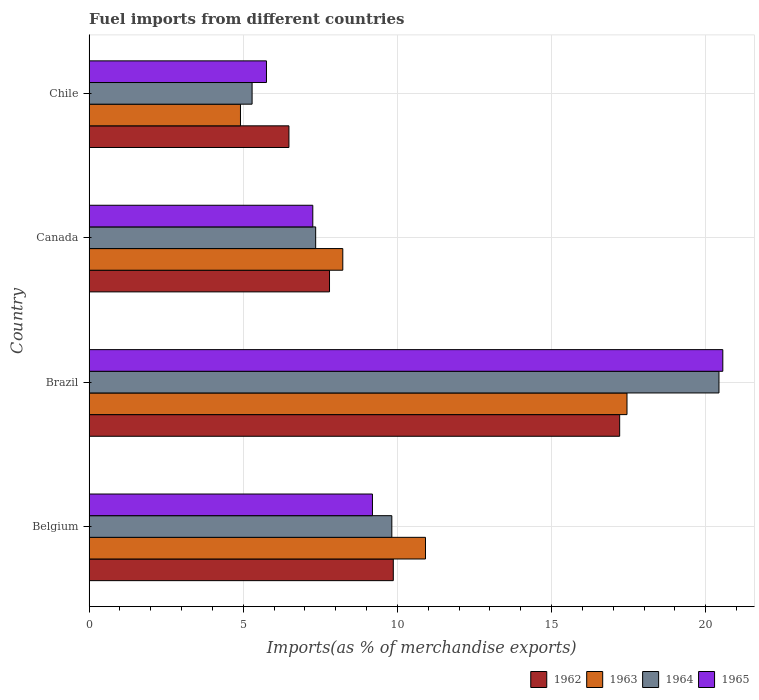How many different coloured bars are there?
Ensure brevity in your answer.  4. How many groups of bars are there?
Offer a terse response. 4. Are the number of bars per tick equal to the number of legend labels?
Ensure brevity in your answer.  Yes. Are the number of bars on each tick of the Y-axis equal?
Make the answer very short. Yes. What is the percentage of imports to different countries in 1964 in Canada?
Your answer should be compact. 7.35. Across all countries, what is the maximum percentage of imports to different countries in 1964?
Your answer should be compact. 20.43. Across all countries, what is the minimum percentage of imports to different countries in 1962?
Offer a terse response. 6.48. In which country was the percentage of imports to different countries in 1963 minimum?
Your answer should be very brief. Chile. What is the total percentage of imports to different countries in 1964 in the graph?
Provide a succinct answer. 42.88. What is the difference between the percentage of imports to different countries in 1964 in Brazil and that in Canada?
Offer a very short reply. 13.08. What is the difference between the percentage of imports to different countries in 1963 in Chile and the percentage of imports to different countries in 1962 in Brazil?
Offer a very short reply. -12.3. What is the average percentage of imports to different countries in 1965 per country?
Provide a succinct answer. 10.69. What is the difference between the percentage of imports to different countries in 1964 and percentage of imports to different countries in 1962 in Belgium?
Offer a very short reply. -0.05. What is the ratio of the percentage of imports to different countries in 1963 in Brazil to that in Chile?
Provide a succinct answer. 3.55. Is the percentage of imports to different countries in 1964 in Belgium less than that in Canada?
Provide a succinct answer. No. Is the difference between the percentage of imports to different countries in 1964 in Belgium and Chile greater than the difference between the percentage of imports to different countries in 1962 in Belgium and Chile?
Provide a short and direct response. Yes. What is the difference between the highest and the second highest percentage of imports to different countries in 1963?
Offer a terse response. 6.54. What is the difference between the highest and the lowest percentage of imports to different countries in 1963?
Your answer should be compact. 12.54. Is it the case that in every country, the sum of the percentage of imports to different countries in 1963 and percentage of imports to different countries in 1962 is greater than the sum of percentage of imports to different countries in 1965 and percentage of imports to different countries in 1964?
Provide a succinct answer. No. What does the 1st bar from the top in Brazil represents?
Offer a very short reply. 1965. What does the 4th bar from the bottom in Brazil represents?
Offer a very short reply. 1965. How many countries are there in the graph?
Your response must be concise. 4. What is the difference between two consecutive major ticks on the X-axis?
Provide a short and direct response. 5. Does the graph contain grids?
Provide a short and direct response. Yes. Where does the legend appear in the graph?
Make the answer very short. Bottom right. How are the legend labels stacked?
Ensure brevity in your answer.  Horizontal. What is the title of the graph?
Offer a terse response. Fuel imports from different countries. Does "1964" appear as one of the legend labels in the graph?
Your answer should be very brief. Yes. What is the label or title of the X-axis?
Keep it short and to the point. Imports(as % of merchandise exports). What is the Imports(as % of merchandise exports) in 1962 in Belgium?
Your answer should be very brief. 9.87. What is the Imports(as % of merchandise exports) in 1963 in Belgium?
Your answer should be compact. 10.91. What is the Imports(as % of merchandise exports) in 1964 in Belgium?
Provide a succinct answer. 9.82. What is the Imports(as % of merchandise exports) in 1965 in Belgium?
Give a very brief answer. 9.19. What is the Imports(as % of merchandise exports) of 1962 in Brazil?
Make the answer very short. 17.21. What is the Imports(as % of merchandise exports) in 1963 in Brazil?
Make the answer very short. 17.45. What is the Imports(as % of merchandise exports) of 1964 in Brazil?
Make the answer very short. 20.43. What is the Imports(as % of merchandise exports) in 1965 in Brazil?
Ensure brevity in your answer.  20.55. What is the Imports(as % of merchandise exports) in 1962 in Canada?
Keep it short and to the point. 7.8. What is the Imports(as % of merchandise exports) in 1963 in Canada?
Offer a very short reply. 8.23. What is the Imports(as % of merchandise exports) of 1964 in Canada?
Provide a succinct answer. 7.35. What is the Imports(as % of merchandise exports) of 1965 in Canada?
Offer a very short reply. 7.26. What is the Imports(as % of merchandise exports) of 1962 in Chile?
Offer a very short reply. 6.48. What is the Imports(as % of merchandise exports) in 1963 in Chile?
Keep it short and to the point. 4.91. What is the Imports(as % of merchandise exports) of 1964 in Chile?
Keep it short and to the point. 5.29. What is the Imports(as % of merchandise exports) of 1965 in Chile?
Offer a terse response. 5.75. Across all countries, what is the maximum Imports(as % of merchandise exports) of 1962?
Ensure brevity in your answer.  17.21. Across all countries, what is the maximum Imports(as % of merchandise exports) in 1963?
Ensure brevity in your answer.  17.45. Across all countries, what is the maximum Imports(as % of merchandise exports) of 1964?
Keep it short and to the point. 20.43. Across all countries, what is the maximum Imports(as % of merchandise exports) in 1965?
Your answer should be compact. 20.55. Across all countries, what is the minimum Imports(as % of merchandise exports) in 1962?
Give a very brief answer. 6.48. Across all countries, what is the minimum Imports(as % of merchandise exports) in 1963?
Ensure brevity in your answer.  4.91. Across all countries, what is the minimum Imports(as % of merchandise exports) in 1964?
Give a very brief answer. 5.29. Across all countries, what is the minimum Imports(as % of merchandise exports) of 1965?
Your response must be concise. 5.75. What is the total Imports(as % of merchandise exports) of 1962 in the graph?
Keep it short and to the point. 41.36. What is the total Imports(as % of merchandise exports) in 1963 in the graph?
Your answer should be compact. 41.5. What is the total Imports(as % of merchandise exports) in 1964 in the graph?
Provide a short and direct response. 42.88. What is the total Imports(as % of merchandise exports) in 1965 in the graph?
Give a very brief answer. 42.75. What is the difference between the Imports(as % of merchandise exports) of 1962 in Belgium and that in Brazil?
Make the answer very short. -7.34. What is the difference between the Imports(as % of merchandise exports) of 1963 in Belgium and that in Brazil?
Offer a very short reply. -6.54. What is the difference between the Imports(as % of merchandise exports) in 1964 in Belgium and that in Brazil?
Keep it short and to the point. -10.61. What is the difference between the Imports(as % of merchandise exports) in 1965 in Belgium and that in Brazil?
Your answer should be compact. -11.36. What is the difference between the Imports(as % of merchandise exports) in 1962 in Belgium and that in Canada?
Offer a very short reply. 2.07. What is the difference between the Imports(as % of merchandise exports) of 1963 in Belgium and that in Canada?
Your answer should be compact. 2.68. What is the difference between the Imports(as % of merchandise exports) in 1964 in Belgium and that in Canada?
Make the answer very short. 2.47. What is the difference between the Imports(as % of merchandise exports) of 1965 in Belgium and that in Canada?
Provide a succinct answer. 1.93. What is the difference between the Imports(as % of merchandise exports) in 1962 in Belgium and that in Chile?
Make the answer very short. 3.39. What is the difference between the Imports(as % of merchandise exports) of 1963 in Belgium and that in Chile?
Offer a terse response. 6. What is the difference between the Imports(as % of merchandise exports) in 1964 in Belgium and that in Chile?
Provide a short and direct response. 4.53. What is the difference between the Imports(as % of merchandise exports) in 1965 in Belgium and that in Chile?
Offer a very short reply. 3.44. What is the difference between the Imports(as % of merchandise exports) of 1962 in Brazil and that in Canada?
Provide a short and direct response. 9.41. What is the difference between the Imports(as % of merchandise exports) of 1963 in Brazil and that in Canada?
Offer a terse response. 9.22. What is the difference between the Imports(as % of merchandise exports) in 1964 in Brazil and that in Canada?
Give a very brief answer. 13.08. What is the difference between the Imports(as % of merchandise exports) of 1965 in Brazil and that in Canada?
Offer a very short reply. 13.3. What is the difference between the Imports(as % of merchandise exports) in 1962 in Brazil and that in Chile?
Make the answer very short. 10.73. What is the difference between the Imports(as % of merchandise exports) in 1963 in Brazil and that in Chile?
Provide a succinct answer. 12.54. What is the difference between the Imports(as % of merchandise exports) of 1964 in Brazil and that in Chile?
Offer a very short reply. 15.14. What is the difference between the Imports(as % of merchandise exports) of 1965 in Brazil and that in Chile?
Ensure brevity in your answer.  14.8. What is the difference between the Imports(as % of merchandise exports) in 1962 in Canada and that in Chile?
Keep it short and to the point. 1.32. What is the difference between the Imports(as % of merchandise exports) in 1963 in Canada and that in Chile?
Offer a very short reply. 3.32. What is the difference between the Imports(as % of merchandise exports) of 1964 in Canada and that in Chile?
Provide a succinct answer. 2.06. What is the difference between the Imports(as % of merchandise exports) of 1965 in Canada and that in Chile?
Make the answer very short. 1.5. What is the difference between the Imports(as % of merchandise exports) of 1962 in Belgium and the Imports(as % of merchandise exports) of 1963 in Brazil?
Provide a short and direct response. -7.58. What is the difference between the Imports(as % of merchandise exports) of 1962 in Belgium and the Imports(as % of merchandise exports) of 1964 in Brazil?
Provide a short and direct response. -10.56. What is the difference between the Imports(as % of merchandise exports) of 1962 in Belgium and the Imports(as % of merchandise exports) of 1965 in Brazil?
Ensure brevity in your answer.  -10.69. What is the difference between the Imports(as % of merchandise exports) in 1963 in Belgium and the Imports(as % of merchandise exports) in 1964 in Brazil?
Your response must be concise. -9.52. What is the difference between the Imports(as % of merchandise exports) of 1963 in Belgium and the Imports(as % of merchandise exports) of 1965 in Brazil?
Provide a short and direct response. -9.64. What is the difference between the Imports(as % of merchandise exports) of 1964 in Belgium and the Imports(as % of merchandise exports) of 1965 in Brazil?
Provide a succinct answer. -10.74. What is the difference between the Imports(as % of merchandise exports) in 1962 in Belgium and the Imports(as % of merchandise exports) in 1963 in Canada?
Keep it short and to the point. 1.64. What is the difference between the Imports(as % of merchandise exports) of 1962 in Belgium and the Imports(as % of merchandise exports) of 1964 in Canada?
Offer a very short reply. 2.52. What is the difference between the Imports(as % of merchandise exports) of 1962 in Belgium and the Imports(as % of merchandise exports) of 1965 in Canada?
Offer a terse response. 2.61. What is the difference between the Imports(as % of merchandise exports) of 1963 in Belgium and the Imports(as % of merchandise exports) of 1964 in Canada?
Your response must be concise. 3.56. What is the difference between the Imports(as % of merchandise exports) of 1963 in Belgium and the Imports(as % of merchandise exports) of 1965 in Canada?
Your answer should be compact. 3.65. What is the difference between the Imports(as % of merchandise exports) in 1964 in Belgium and the Imports(as % of merchandise exports) in 1965 in Canada?
Give a very brief answer. 2.56. What is the difference between the Imports(as % of merchandise exports) in 1962 in Belgium and the Imports(as % of merchandise exports) in 1963 in Chile?
Offer a terse response. 4.96. What is the difference between the Imports(as % of merchandise exports) of 1962 in Belgium and the Imports(as % of merchandise exports) of 1964 in Chile?
Keep it short and to the point. 4.58. What is the difference between the Imports(as % of merchandise exports) in 1962 in Belgium and the Imports(as % of merchandise exports) in 1965 in Chile?
Keep it short and to the point. 4.11. What is the difference between the Imports(as % of merchandise exports) in 1963 in Belgium and the Imports(as % of merchandise exports) in 1964 in Chile?
Provide a short and direct response. 5.62. What is the difference between the Imports(as % of merchandise exports) in 1963 in Belgium and the Imports(as % of merchandise exports) in 1965 in Chile?
Make the answer very short. 5.16. What is the difference between the Imports(as % of merchandise exports) in 1964 in Belgium and the Imports(as % of merchandise exports) in 1965 in Chile?
Offer a very short reply. 4.07. What is the difference between the Imports(as % of merchandise exports) of 1962 in Brazil and the Imports(as % of merchandise exports) of 1963 in Canada?
Provide a short and direct response. 8.98. What is the difference between the Imports(as % of merchandise exports) of 1962 in Brazil and the Imports(as % of merchandise exports) of 1964 in Canada?
Offer a very short reply. 9.86. What is the difference between the Imports(as % of merchandise exports) in 1962 in Brazil and the Imports(as % of merchandise exports) in 1965 in Canada?
Your answer should be very brief. 9.95. What is the difference between the Imports(as % of merchandise exports) of 1963 in Brazil and the Imports(as % of merchandise exports) of 1964 in Canada?
Your answer should be very brief. 10.1. What is the difference between the Imports(as % of merchandise exports) of 1963 in Brazil and the Imports(as % of merchandise exports) of 1965 in Canada?
Provide a succinct answer. 10.19. What is the difference between the Imports(as % of merchandise exports) in 1964 in Brazil and the Imports(as % of merchandise exports) in 1965 in Canada?
Offer a terse response. 13.17. What is the difference between the Imports(as % of merchandise exports) of 1962 in Brazil and the Imports(as % of merchandise exports) of 1963 in Chile?
Ensure brevity in your answer.  12.3. What is the difference between the Imports(as % of merchandise exports) of 1962 in Brazil and the Imports(as % of merchandise exports) of 1964 in Chile?
Ensure brevity in your answer.  11.92. What is the difference between the Imports(as % of merchandise exports) of 1962 in Brazil and the Imports(as % of merchandise exports) of 1965 in Chile?
Ensure brevity in your answer.  11.46. What is the difference between the Imports(as % of merchandise exports) of 1963 in Brazil and the Imports(as % of merchandise exports) of 1964 in Chile?
Provide a short and direct response. 12.16. What is the difference between the Imports(as % of merchandise exports) in 1963 in Brazil and the Imports(as % of merchandise exports) in 1965 in Chile?
Provide a short and direct response. 11.69. What is the difference between the Imports(as % of merchandise exports) of 1964 in Brazil and the Imports(as % of merchandise exports) of 1965 in Chile?
Provide a short and direct response. 14.68. What is the difference between the Imports(as % of merchandise exports) of 1962 in Canada and the Imports(as % of merchandise exports) of 1963 in Chile?
Your answer should be compact. 2.89. What is the difference between the Imports(as % of merchandise exports) in 1962 in Canada and the Imports(as % of merchandise exports) in 1964 in Chile?
Keep it short and to the point. 2.51. What is the difference between the Imports(as % of merchandise exports) in 1962 in Canada and the Imports(as % of merchandise exports) in 1965 in Chile?
Ensure brevity in your answer.  2.04. What is the difference between the Imports(as % of merchandise exports) of 1963 in Canada and the Imports(as % of merchandise exports) of 1964 in Chile?
Provide a short and direct response. 2.94. What is the difference between the Imports(as % of merchandise exports) of 1963 in Canada and the Imports(as % of merchandise exports) of 1965 in Chile?
Offer a very short reply. 2.48. What is the difference between the Imports(as % of merchandise exports) of 1964 in Canada and the Imports(as % of merchandise exports) of 1965 in Chile?
Offer a very short reply. 1.6. What is the average Imports(as % of merchandise exports) of 1962 per country?
Your answer should be compact. 10.34. What is the average Imports(as % of merchandise exports) in 1963 per country?
Provide a short and direct response. 10.37. What is the average Imports(as % of merchandise exports) in 1964 per country?
Provide a short and direct response. 10.72. What is the average Imports(as % of merchandise exports) of 1965 per country?
Make the answer very short. 10.69. What is the difference between the Imports(as % of merchandise exports) in 1962 and Imports(as % of merchandise exports) in 1963 in Belgium?
Your answer should be compact. -1.04. What is the difference between the Imports(as % of merchandise exports) of 1962 and Imports(as % of merchandise exports) of 1964 in Belgium?
Keep it short and to the point. 0.05. What is the difference between the Imports(as % of merchandise exports) of 1962 and Imports(as % of merchandise exports) of 1965 in Belgium?
Keep it short and to the point. 0.68. What is the difference between the Imports(as % of merchandise exports) in 1963 and Imports(as % of merchandise exports) in 1964 in Belgium?
Provide a succinct answer. 1.09. What is the difference between the Imports(as % of merchandise exports) of 1963 and Imports(as % of merchandise exports) of 1965 in Belgium?
Your response must be concise. 1.72. What is the difference between the Imports(as % of merchandise exports) of 1964 and Imports(as % of merchandise exports) of 1965 in Belgium?
Your answer should be compact. 0.63. What is the difference between the Imports(as % of merchandise exports) of 1962 and Imports(as % of merchandise exports) of 1963 in Brazil?
Your response must be concise. -0.24. What is the difference between the Imports(as % of merchandise exports) in 1962 and Imports(as % of merchandise exports) in 1964 in Brazil?
Make the answer very short. -3.22. What is the difference between the Imports(as % of merchandise exports) of 1962 and Imports(as % of merchandise exports) of 1965 in Brazil?
Keep it short and to the point. -3.35. What is the difference between the Imports(as % of merchandise exports) of 1963 and Imports(as % of merchandise exports) of 1964 in Brazil?
Keep it short and to the point. -2.98. What is the difference between the Imports(as % of merchandise exports) of 1963 and Imports(as % of merchandise exports) of 1965 in Brazil?
Your answer should be compact. -3.11. What is the difference between the Imports(as % of merchandise exports) of 1964 and Imports(as % of merchandise exports) of 1965 in Brazil?
Give a very brief answer. -0.12. What is the difference between the Imports(as % of merchandise exports) in 1962 and Imports(as % of merchandise exports) in 1963 in Canada?
Give a very brief answer. -0.43. What is the difference between the Imports(as % of merchandise exports) in 1962 and Imports(as % of merchandise exports) in 1964 in Canada?
Ensure brevity in your answer.  0.45. What is the difference between the Imports(as % of merchandise exports) in 1962 and Imports(as % of merchandise exports) in 1965 in Canada?
Ensure brevity in your answer.  0.54. What is the difference between the Imports(as % of merchandise exports) of 1963 and Imports(as % of merchandise exports) of 1964 in Canada?
Your answer should be compact. 0.88. What is the difference between the Imports(as % of merchandise exports) in 1963 and Imports(as % of merchandise exports) in 1965 in Canada?
Give a very brief answer. 0.97. What is the difference between the Imports(as % of merchandise exports) in 1964 and Imports(as % of merchandise exports) in 1965 in Canada?
Your answer should be very brief. 0.09. What is the difference between the Imports(as % of merchandise exports) in 1962 and Imports(as % of merchandise exports) in 1963 in Chile?
Offer a terse response. 1.57. What is the difference between the Imports(as % of merchandise exports) in 1962 and Imports(as % of merchandise exports) in 1964 in Chile?
Make the answer very short. 1.19. What is the difference between the Imports(as % of merchandise exports) of 1962 and Imports(as % of merchandise exports) of 1965 in Chile?
Offer a terse response. 0.73. What is the difference between the Imports(as % of merchandise exports) in 1963 and Imports(as % of merchandise exports) in 1964 in Chile?
Your response must be concise. -0.38. What is the difference between the Imports(as % of merchandise exports) of 1963 and Imports(as % of merchandise exports) of 1965 in Chile?
Offer a very short reply. -0.84. What is the difference between the Imports(as % of merchandise exports) in 1964 and Imports(as % of merchandise exports) in 1965 in Chile?
Your answer should be very brief. -0.47. What is the ratio of the Imports(as % of merchandise exports) of 1962 in Belgium to that in Brazil?
Provide a succinct answer. 0.57. What is the ratio of the Imports(as % of merchandise exports) of 1963 in Belgium to that in Brazil?
Keep it short and to the point. 0.63. What is the ratio of the Imports(as % of merchandise exports) in 1964 in Belgium to that in Brazil?
Offer a very short reply. 0.48. What is the ratio of the Imports(as % of merchandise exports) of 1965 in Belgium to that in Brazil?
Provide a short and direct response. 0.45. What is the ratio of the Imports(as % of merchandise exports) in 1962 in Belgium to that in Canada?
Provide a short and direct response. 1.27. What is the ratio of the Imports(as % of merchandise exports) in 1963 in Belgium to that in Canada?
Provide a succinct answer. 1.33. What is the ratio of the Imports(as % of merchandise exports) of 1964 in Belgium to that in Canada?
Keep it short and to the point. 1.34. What is the ratio of the Imports(as % of merchandise exports) in 1965 in Belgium to that in Canada?
Your response must be concise. 1.27. What is the ratio of the Imports(as % of merchandise exports) in 1962 in Belgium to that in Chile?
Ensure brevity in your answer.  1.52. What is the ratio of the Imports(as % of merchandise exports) in 1963 in Belgium to that in Chile?
Provide a succinct answer. 2.22. What is the ratio of the Imports(as % of merchandise exports) in 1964 in Belgium to that in Chile?
Provide a short and direct response. 1.86. What is the ratio of the Imports(as % of merchandise exports) in 1965 in Belgium to that in Chile?
Provide a short and direct response. 1.6. What is the ratio of the Imports(as % of merchandise exports) in 1962 in Brazil to that in Canada?
Make the answer very short. 2.21. What is the ratio of the Imports(as % of merchandise exports) in 1963 in Brazil to that in Canada?
Your response must be concise. 2.12. What is the ratio of the Imports(as % of merchandise exports) in 1964 in Brazil to that in Canada?
Give a very brief answer. 2.78. What is the ratio of the Imports(as % of merchandise exports) of 1965 in Brazil to that in Canada?
Make the answer very short. 2.83. What is the ratio of the Imports(as % of merchandise exports) of 1962 in Brazil to that in Chile?
Make the answer very short. 2.65. What is the ratio of the Imports(as % of merchandise exports) of 1963 in Brazil to that in Chile?
Your answer should be very brief. 3.55. What is the ratio of the Imports(as % of merchandise exports) in 1964 in Brazil to that in Chile?
Offer a terse response. 3.86. What is the ratio of the Imports(as % of merchandise exports) in 1965 in Brazil to that in Chile?
Make the answer very short. 3.57. What is the ratio of the Imports(as % of merchandise exports) in 1962 in Canada to that in Chile?
Offer a terse response. 1.2. What is the ratio of the Imports(as % of merchandise exports) of 1963 in Canada to that in Chile?
Provide a succinct answer. 1.68. What is the ratio of the Imports(as % of merchandise exports) in 1964 in Canada to that in Chile?
Ensure brevity in your answer.  1.39. What is the ratio of the Imports(as % of merchandise exports) in 1965 in Canada to that in Chile?
Your response must be concise. 1.26. What is the difference between the highest and the second highest Imports(as % of merchandise exports) in 1962?
Offer a very short reply. 7.34. What is the difference between the highest and the second highest Imports(as % of merchandise exports) of 1963?
Your answer should be very brief. 6.54. What is the difference between the highest and the second highest Imports(as % of merchandise exports) in 1964?
Your answer should be compact. 10.61. What is the difference between the highest and the second highest Imports(as % of merchandise exports) in 1965?
Provide a succinct answer. 11.36. What is the difference between the highest and the lowest Imports(as % of merchandise exports) of 1962?
Give a very brief answer. 10.73. What is the difference between the highest and the lowest Imports(as % of merchandise exports) in 1963?
Give a very brief answer. 12.54. What is the difference between the highest and the lowest Imports(as % of merchandise exports) of 1964?
Give a very brief answer. 15.14. What is the difference between the highest and the lowest Imports(as % of merchandise exports) of 1965?
Your response must be concise. 14.8. 